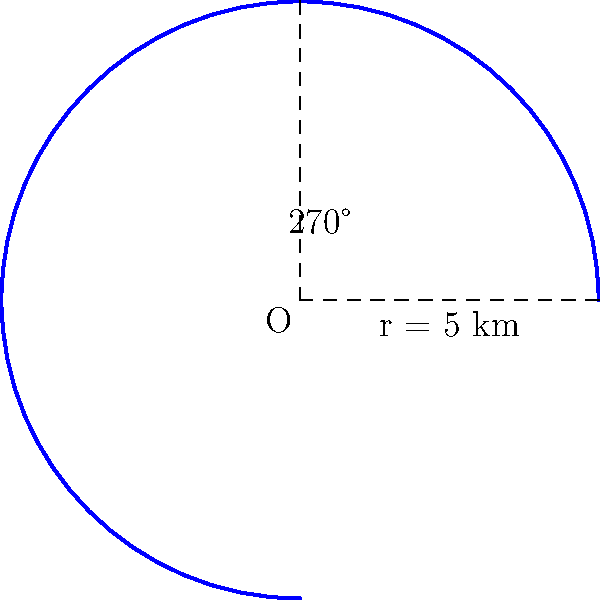As a philanthropist organizing a marathon for charity, you've designed a unique curved route that follows 3/4 of a circular path. If the radius of this circular path is 5 km, what is the total length of the marathon route? Round your answer to the nearest tenth of a kilometer. To solve this problem, we'll use the arc length formula for a circular path. Here's the step-by-step solution:

1) The arc length formula is:
   $$s = r\theta$$
   where $s$ is the arc length, $r$ is the radius, and $\theta$ is the central angle in radians.

2) We're given:
   - Radius $r = 5$ km
   - The route covers 3/4 of a circle, which is equivalent to 270°

3) Convert 270° to radians:
   $$\theta = 270° \times \frac{\pi}{180°} = \frac{3\pi}{2}$$ radians

4) Now, let's apply the arc length formula:
   $$s = r\theta = 5 \times \frac{3\pi}{2}$$

5) Calculate:
   $$s = \frac{15\pi}{2} \approx 23.56194490192345$$ km

6) Rounding to the nearest tenth:
   $$s \approx 23.6$$ km

Therefore, the total length of the marathon route is approximately 23.6 km.
Answer: 23.6 km 